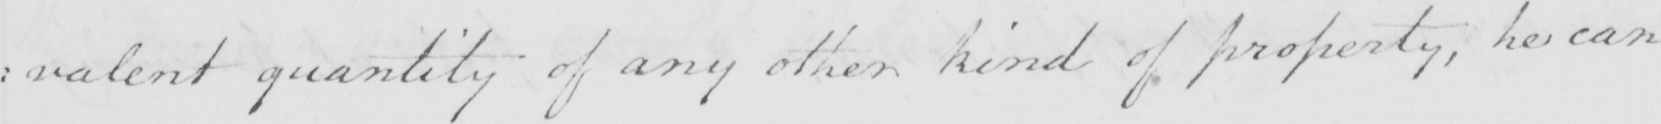Can you read and transcribe this handwriting? : valent quantity of any other kind of property , he can 